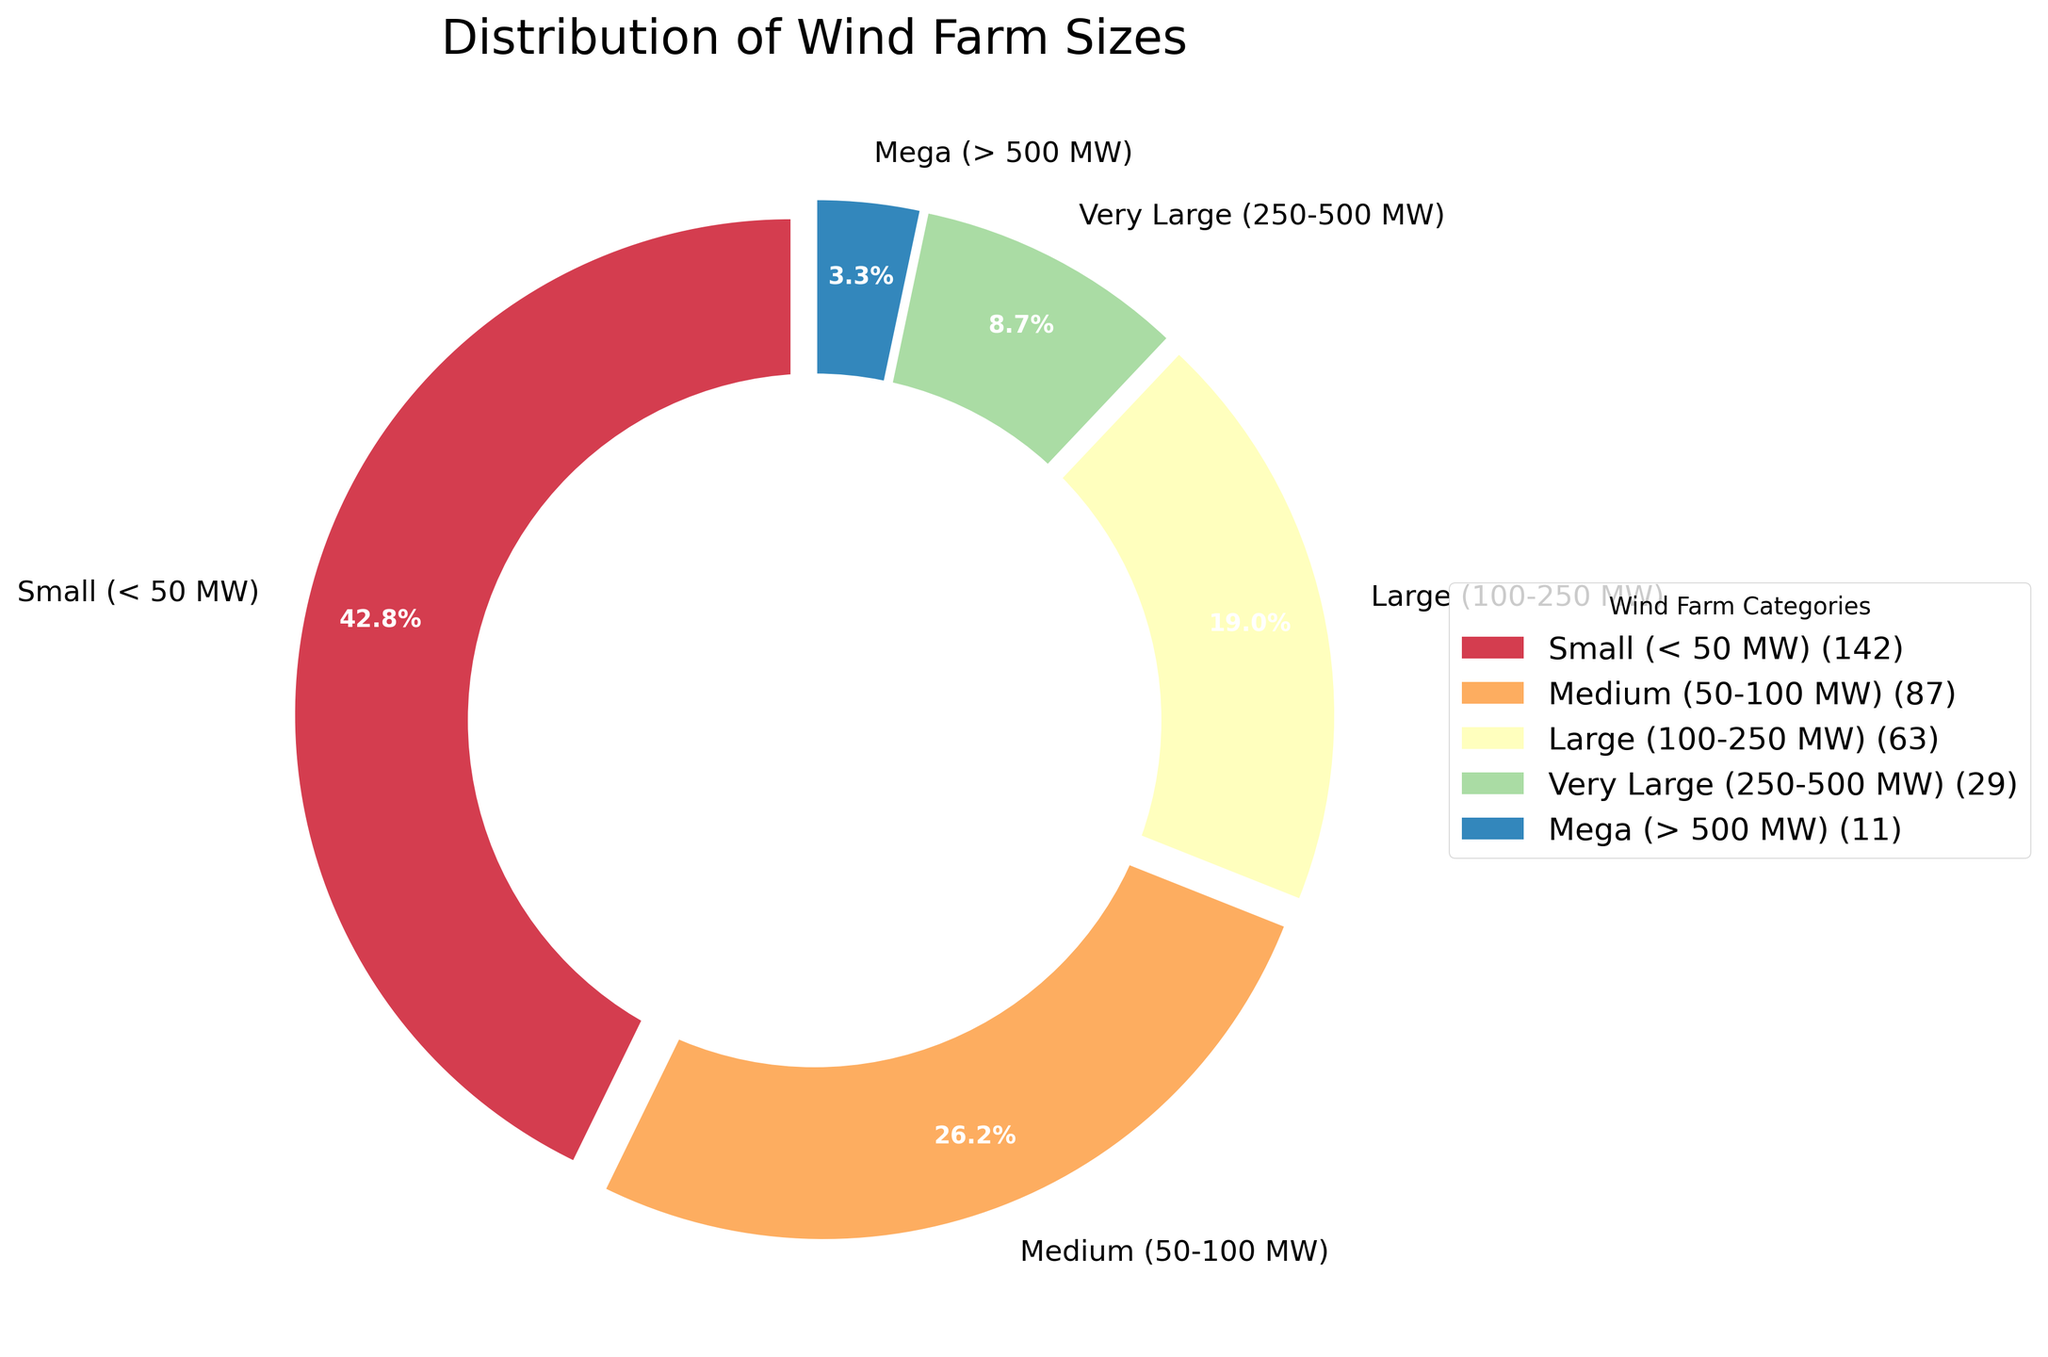Which category has the largest percentage of wind farms? The chart shows the percentage distribution of each category. The category with the largest percentage will have the biggest portion in the pie chart.
Answer: Small (< 50 MW) How many wind farms are there in the 'Large' category? The legend beside the chart lists the number of wind farms for each category in parentheses.
Answer: 63 How do the number of wind farms in the 'Mega' and 'Medium' categories compare? To compare the two categories, look at their respective values and determine which one is higher. The 'Medium' category has 87 wind farms, while 'Mega' has 11.
Answer: 'Medium' has more wind farms than 'Mega' What percentage of wind farms are 'Very Large'? The pie chart displays percentages within each segment. Locate the 'Very Large' segment to find its percentage value.
Answer: 8.8% Are there more 'Small' wind farms than the combined total of 'Large' and 'Very Large' wind farms? Sum the number of 'Large' (63) and 'Very Large' (29), which gives 92. Compare this to the number of 'Small' wind farms, which is 142.
Answer: Yes, there are more 'Small' wind farms What is the sum of wind farms in categories larger than 100 MW? Sum the number of wind farms in 'Large' (63), 'Very Large' (29), and 'Mega' (11) categories. This gives 103.
Answer: 103 Is the 'Medium' category closer in count to the 'Small' or 'Large' category? Compare the count of the 'Medium' category (87) to both 'Small' (142) and 'Large' (63). The difference from 'Medium' to 'Small' is 55, while to 'Large' it is 24.
Answer: Closer to 'Large' Which category occupies the smallest portion of the pie chart? Look for the smallest segment of the pie chart. The 'Mega' category appears to be the smallest.
Answer: Mega (> 500 MW) What color represents the 'Medium' wind farm category in the chart? Observe the colors used in the pie chart and their corresponding labels. The 'Medium' category is represented by an intermediate shade in the color spectrum used.
Answer: Intermediate shade (specific color depends on the rendering) 